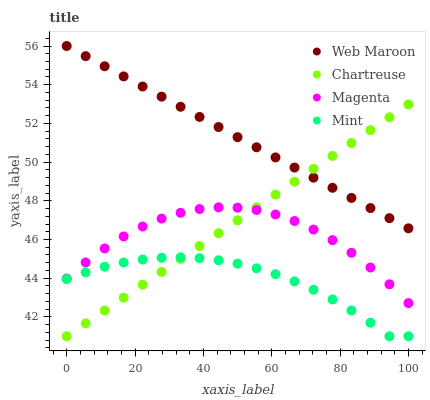Does Mint have the minimum area under the curve?
Answer yes or no. Yes. Does Web Maroon have the maximum area under the curve?
Answer yes or no. Yes. Does Chartreuse have the minimum area under the curve?
Answer yes or no. No. Does Chartreuse have the maximum area under the curve?
Answer yes or no. No. Is Chartreuse the smoothest?
Answer yes or no. Yes. Is Magenta the roughest?
Answer yes or no. Yes. Is Web Maroon the smoothest?
Answer yes or no. No. Is Web Maroon the roughest?
Answer yes or no. No. Does Mint have the lowest value?
Answer yes or no. Yes. Does Web Maroon have the lowest value?
Answer yes or no. No. Does Web Maroon have the highest value?
Answer yes or no. Yes. Does Chartreuse have the highest value?
Answer yes or no. No. Is Magenta less than Web Maroon?
Answer yes or no. Yes. Is Magenta greater than Mint?
Answer yes or no. Yes. Does Chartreuse intersect Web Maroon?
Answer yes or no. Yes. Is Chartreuse less than Web Maroon?
Answer yes or no. No. Is Chartreuse greater than Web Maroon?
Answer yes or no. No. Does Magenta intersect Web Maroon?
Answer yes or no. No. 